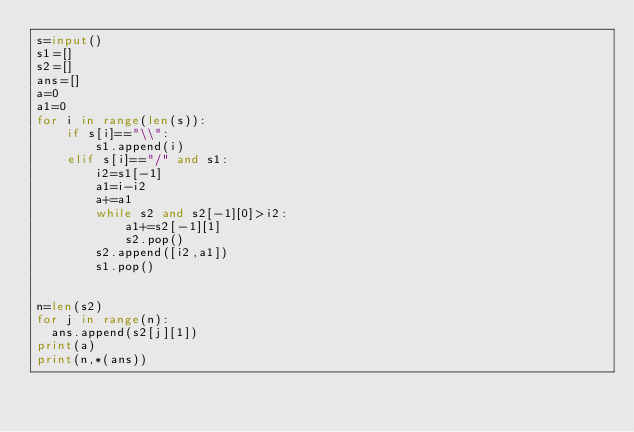<code> <loc_0><loc_0><loc_500><loc_500><_Python_>s=input()
s1=[]
s2=[]
ans=[]
a=0
a1=0
for i in range(len(s)):
    if s[i]=="\\":
        s1.append(i)
    elif s[i]=="/" and s1:
        i2=s1[-1]
        a1=i-i2
        a+=a1
        while s2 and s2[-1][0]>i2:
            a1+=s2[-1][1]
            s2.pop()
        s2.append([i2,a1])
        s1.pop()


n=len(s2)
for j in range(n):
  ans.append(s2[j][1])
print(a)
print(n,*(ans))
</code> 